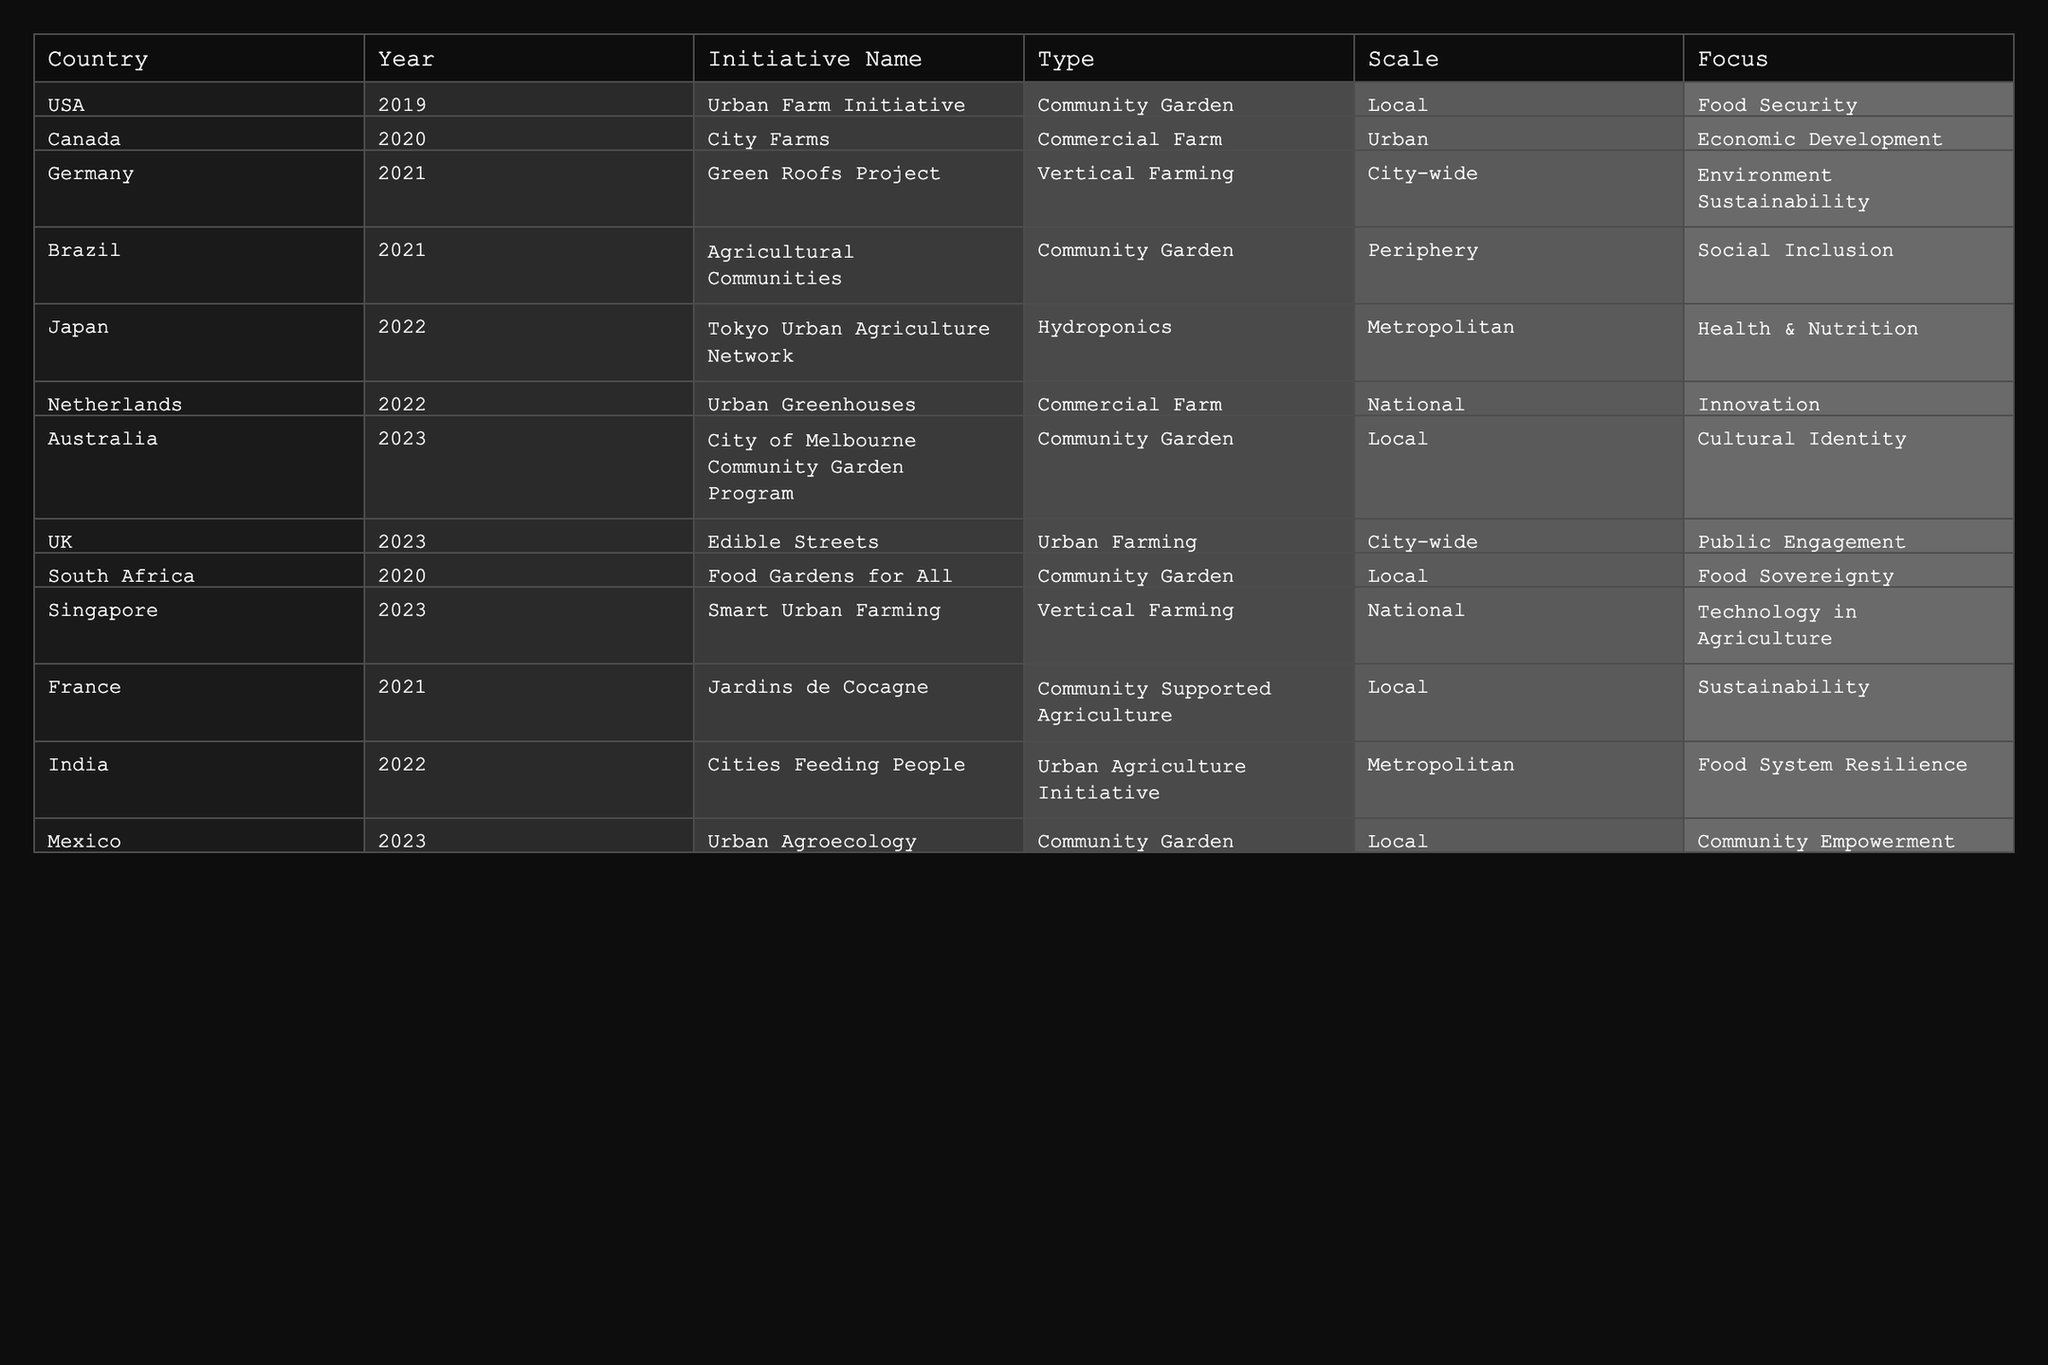What urban agriculture initiative was launched in Canada in 2020? The table indicates that "City Farms" is the urban agriculture initiative launched in Canada in 2020.
Answer: City Farms Which country has the highest number of initiatives in the data provided? The data shows initiatives from the USA, Canada, Germany, Brazil, Japan, Netherlands, Australia, UK, South Africa, Singapore, France, India, and Mexico. Counting reveals that the USA has 1 initiative, the most among the listed countries.
Answer: USA Is the "Edible Streets" initiative focused on public engagement? According to the table, the focus for "Edible Streets" is indeed public engagement, confirming the statement as true.
Answer: True How many urban agriculture initiatives focused on food security are listed for the years 2019 to 2023? The table shows only one initiative focused on food security: the "Urban Farm Initiative" in the USA for 2019. No other initiatives listed for 2020 to 2023 focus on food security, resulting in a total count of one.
Answer: 1 Which type of urban agriculture initiative has gained the most attention in 2022 across different countries? In 2022, there are three different types of initiatives listed: Hydroponics (Japan), Commercial Farm (Netherlands), and a Urban Agriculture Initiative (India). Thus, no specific type has more initiatives than another for that year.
Answer: None What is the average scale of initiatives across all countries in the table? The scales range across "Local," "Urban," "City-wide," "Metropolitan," and "National." When counting, each scale appears as follows: Local (5), Urban (2), City-wide (3), Metropolitan (2), National (3). To find the average: (5+2+3+2+3)/5 = 15/5 = 3. There are 5 different scale types used.
Answer: 3 Which initiative in the data is focused on technology in agriculture? The table states that "Smart Urban Farming" in Singapore for 2023 is the only initiative that specifically highlights technology in agriculture as its focus.
Answer: Smart Urban Farming Did Brazil have an urban agriculture initiative in 2019? Checking the table indicates that Brazil's initiative, "Agricultural Communities," was launched in 2021, not 2019, confirming that the statement is false.
Answer: False What are the two dominant focuses of urban agriculture initiatives listed for 2023? The table reveals that community empowerment (Mexico) and technology in agriculture (Singapore) are the focuses of the two initiatives in 2023. So, these are the two dominant focuses of that year.
Answer: Community Empowerment and Technology in Agriculture 